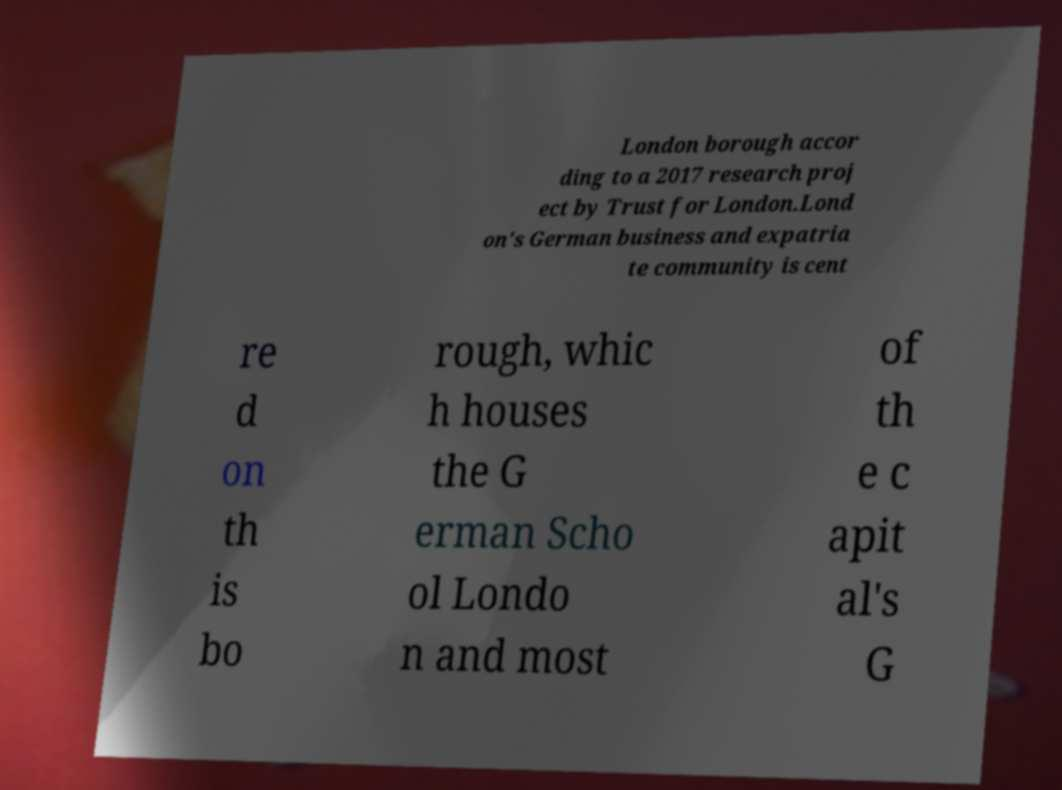Could you extract and type out the text from this image? London borough accor ding to a 2017 research proj ect by Trust for London.Lond on's German business and expatria te community is cent re d on th is bo rough, whic h houses the G erman Scho ol Londo n and most of th e c apit al's G 